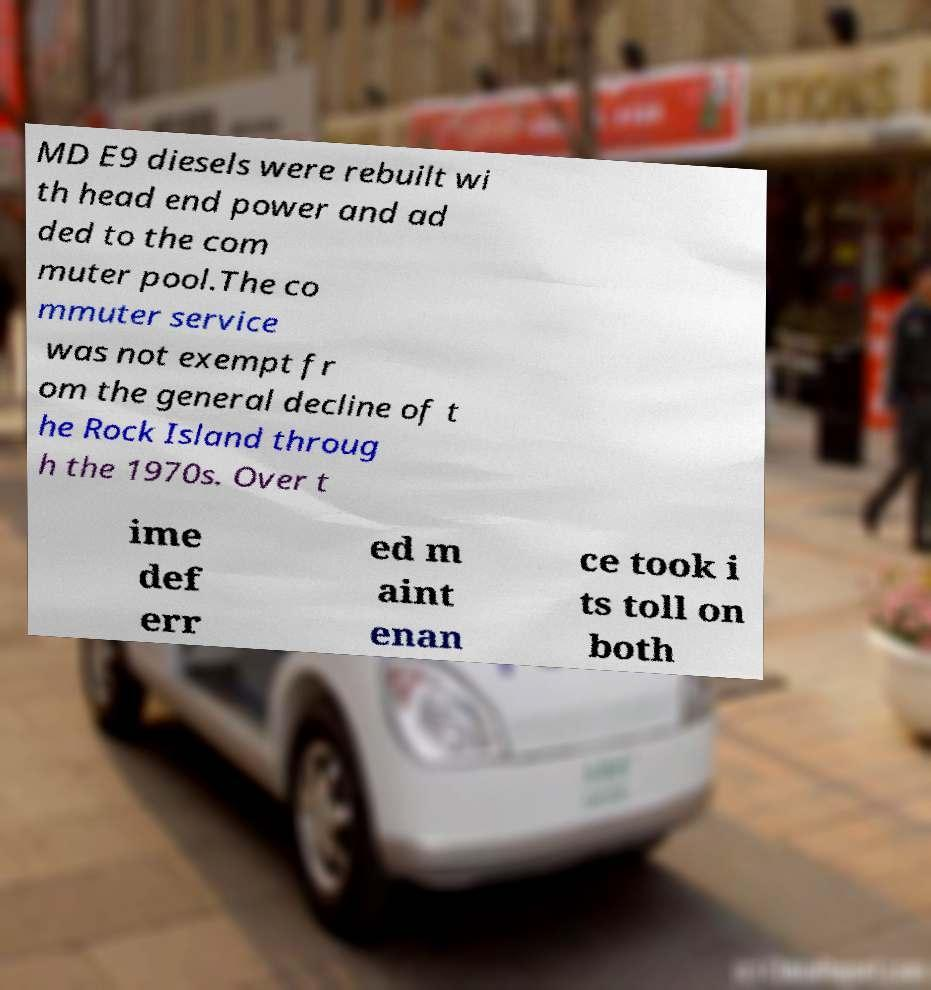Please read and relay the text visible in this image. What does it say? MD E9 diesels were rebuilt wi th head end power and ad ded to the com muter pool.The co mmuter service was not exempt fr om the general decline of t he Rock Island throug h the 1970s. Over t ime def err ed m aint enan ce took i ts toll on both 